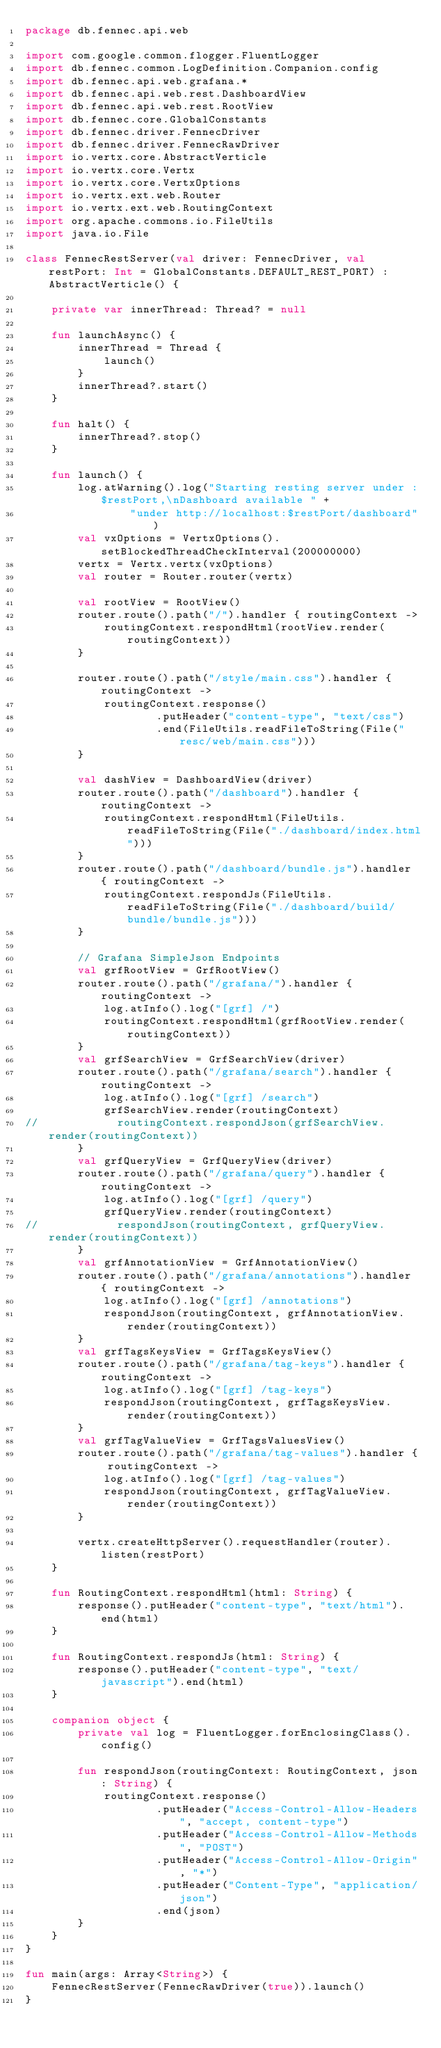<code> <loc_0><loc_0><loc_500><loc_500><_Kotlin_>package db.fennec.api.web

import com.google.common.flogger.FluentLogger
import db.fennec.common.LogDefinition.Companion.config
import db.fennec.api.web.grafana.*
import db.fennec.api.web.rest.DashboardView
import db.fennec.api.web.rest.RootView
import db.fennec.core.GlobalConstants
import db.fennec.driver.FennecDriver
import db.fennec.driver.FennecRawDriver
import io.vertx.core.AbstractVerticle
import io.vertx.core.Vertx
import io.vertx.core.VertxOptions
import io.vertx.ext.web.Router
import io.vertx.ext.web.RoutingContext
import org.apache.commons.io.FileUtils
import java.io.File

class FennecRestServer(val driver: FennecDriver, val restPort: Int = GlobalConstants.DEFAULT_REST_PORT) : AbstractVerticle() {

    private var innerThread: Thread? = null

    fun launchAsync() {
        innerThread = Thread {
            launch()
        }
        innerThread?.start()
    }

    fun halt() {
        innerThread?.stop()
    }

    fun launch() {
        log.atWarning().log("Starting resting server under :$restPort,\nDashboard available " +
                "under http://localhost:$restPort/dashboard")
        val vxOptions = VertxOptions().setBlockedThreadCheckInterval(200000000)
        vertx = Vertx.vertx(vxOptions)
        val router = Router.router(vertx)

        val rootView = RootView()
        router.route().path("/").handler { routingContext ->
            routingContext.respondHtml(rootView.render(routingContext))
        }

        router.route().path("/style/main.css").handler { routingContext ->
            routingContext.response()
                    .putHeader("content-type", "text/css")
                    .end(FileUtils.readFileToString(File("resc/web/main.css")))
        }

        val dashView = DashboardView(driver)
        router.route().path("/dashboard").handler { routingContext ->
            routingContext.respondHtml(FileUtils.readFileToString(File("./dashboard/index.html")))
        }
        router.route().path("/dashboard/bundle.js").handler { routingContext ->
            routingContext.respondJs(FileUtils.readFileToString(File("./dashboard/build/bundle/bundle.js")))
        }

        // Grafana SimpleJson Endpoints
        val grfRootView = GrfRootView()
        router.route().path("/grafana/").handler { routingContext ->
            log.atInfo().log("[grf] /")
            routingContext.respondHtml(grfRootView.render(routingContext))
        }
        val grfSearchView = GrfSearchView(driver)
        router.route().path("/grafana/search").handler { routingContext ->
            log.atInfo().log("[grf] /search")
            grfSearchView.render(routingContext)
//            routingContext.respondJson(grfSearchView.render(routingContext))
        }
        val grfQueryView = GrfQueryView(driver)
        router.route().path("/grafana/query").handler { routingContext ->
            log.atInfo().log("[grf] /query")
            grfQueryView.render(routingContext)
//            respondJson(routingContext, grfQueryView.render(routingContext))
        }
        val grfAnnotationView = GrfAnnotationView()
        router.route().path("/grafana/annotations").handler { routingContext ->
            log.atInfo().log("[grf] /annotations")
            respondJson(routingContext, grfAnnotationView.render(routingContext))
        }
        val grfTagsKeysView = GrfTagsKeysView()
        router.route().path("/grafana/tag-keys").handler { routingContext ->
            log.atInfo().log("[grf] /tag-keys")
            respondJson(routingContext, grfTagsKeysView.render(routingContext))
        }
        val grfTagValueView = GrfTagsValuesView()
        router.route().path("/grafana/tag-values").handler { routingContext ->
            log.atInfo().log("[grf] /tag-values")
            respondJson(routingContext, grfTagValueView.render(routingContext))
        }

        vertx.createHttpServer().requestHandler(router).listen(restPort)
    }

    fun RoutingContext.respondHtml(html: String) {
        response().putHeader("content-type", "text/html").end(html)
    }

    fun RoutingContext.respondJs(html: String) {
        response().putHeader("content-type", "text/javascript").end(html)
    }

    companion object {
        private val log = FluentLogger.forEnclosingClass().config()

        fun respondJson(routingContext: RoutingContext, json: String) {
            routingContext.response()
                    .putHeader("Access-Control-Allow-Headers", "accept, content-type")
                    .putHeader("Access-Control-Allow-Methods", "POST")
                    .putHeader("Access-Control-Allow-Origin", "*")
                    .putHeader("Content-Type", "application/json")
                    .end(json)
        }
    }
}

fun main(args: Array<String>) {
    FennecRestServer(FennecRawDriver(true)).launch()
}
</code> 